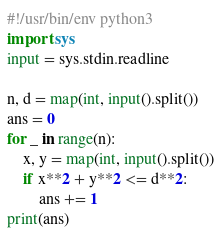Convert code to text. <code><loc_0><loc_0><loc_500><loc_500><_Python_>#!/usr/bin/env python3
import sys
input = sys.stdin.readline

n, d = map(int, input().split())
ans = 0
for _ in range(n):
    x, y = map(int, input().split())
    if x**2 + y**2 <= d**2:
        ans += 1
print(ans)</code> 